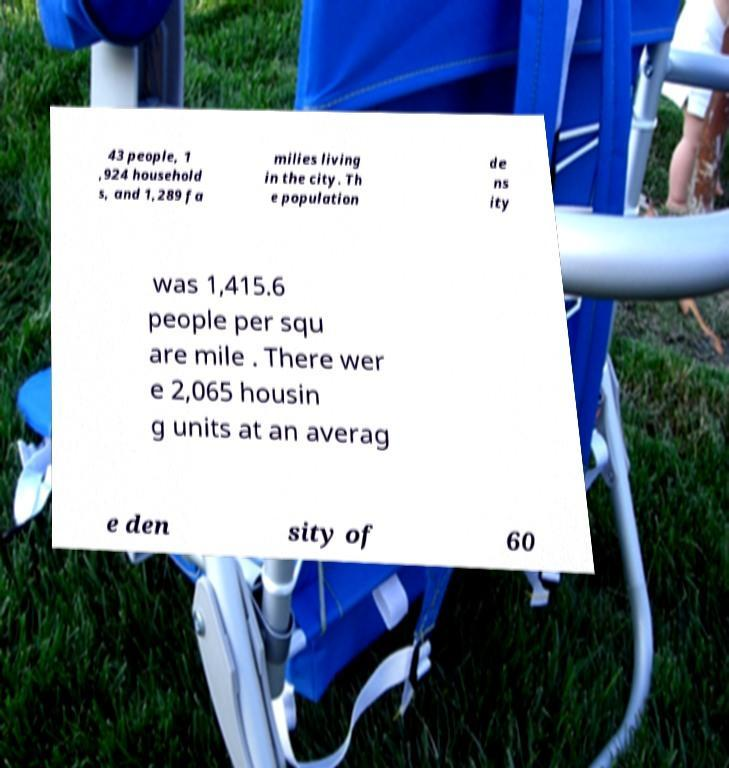Could you assist in decoding the text presented in this image and type it out clearly? 43 people, 1 ,924 household s, and 1,289 fa milies living in the city. Th e population de ns ity was 1,415.6 people per squ are mile . There wer e 2,065 housin g units at an averag e den sity of 60 